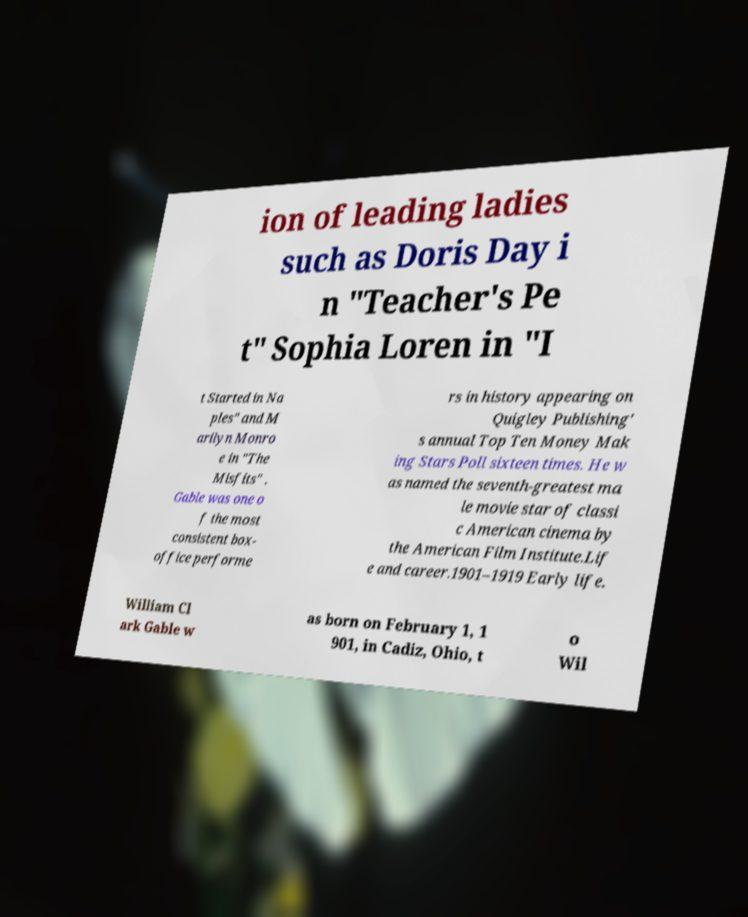Could you extract and type out the text from this image? ion of leading ladies such as Doris Day i n "Teacher's Pe t" Sophia Loren in "I t Started in Na ples" and M arilyn Monro e in "The Misfits" . Gable was one o f the most consistent box- office performe rs in history appearing on Quigley Publishing' s annual Top Ten Money Mak ing Stars Poll sixteen times. He w as named the seventh-greatest ma le movie star of classi c American cinema by the American Film Institute.Lif e and career.1901–1919 Early life. William Cl ark Gable w as born on February 1, 1 901, in Cadiz, Ohio, t o Wil 